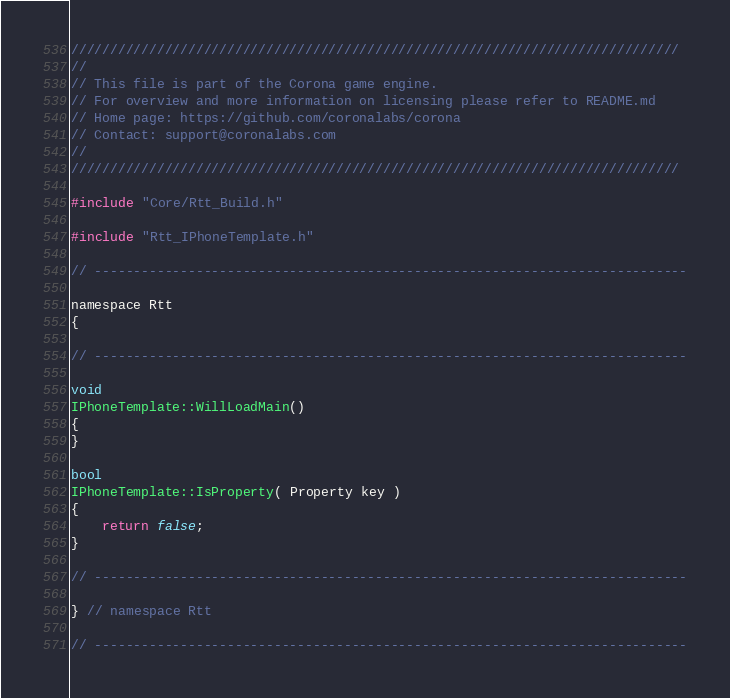<code> <loc_0><loc_0><loc_500><loc_500><_ObjectiveC_>//////////////////////////////////////////////////////////////////////////////
//
// This file is part of the Corona game engine.
// For overview and more information on licensing please refer to README.md 
// Home page: https://github.com/coronalabs/corona
// Contact: support@coronalabs.com
//
//////////////////////////////////////////////////////////////////////////////

#include "Core/Rtt_Build.h"

#include "Rtt_IPhoneTemplate.h"

// ----------------------------------------------------------------------------

namespace Rtt
{

// ----------------------------------------------------------------------------

void
IPhoneTemplate::WillLoadMain()
{
}

bool
IPhoneTemplate::IsProperty( Property key )
{
	return false;
}

// ----------------------------------------------------------------------------

} // namespace Rtt

// ----------------------------------------------------------------------------

</code> 